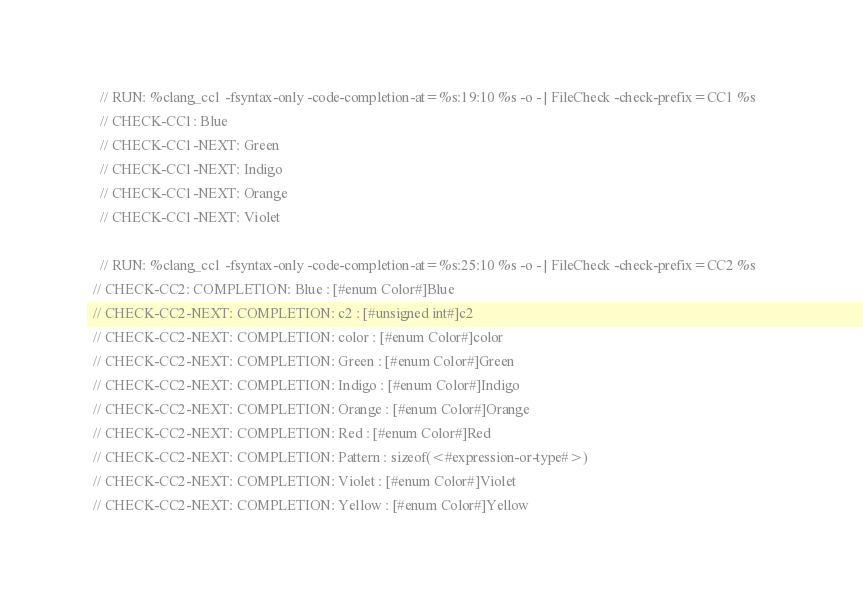<code> <loc_0><loc_0><loc_500><loc_500><_C_>
    // RUN: %clang_cc1 -fsyntax-only -code-completion-at=%s:19:10 %s -o - | FileCheck -check-prefix=CC1 %s
    // CHECK-CC1: Blue
    // CHECK-CC1-NEXT: Green
    // CHECK-CC1-NEXT: Indigo
    // CHECK-CC1-NEXT: Orange
    // CHECK-CC1-NEXT: Violet

    // RUN: %clang_cc1 -fsyntax-only -code-completion-at=%s:25:10 %s -o - | FileCheck -check-prefix=CC2 %s      
  // CHECK-CC2: COMPLETION: Blue : [#enum Color#]Blue
  // CHECK-CC2-NEXT: COMPLETION: c2 : [#unsigned int#]c2
  // CHECK-CC2-NEXT: COMPLETION: color : [#enum Color#]color
  // CHECK-CC2-NEXT: COMPLETION: Green : [#enum Color#]Green
  // CHECK-CC2-NEXT: COMPLETION: Indigo : [#enum Color#]Indigo
  // CHECK-CC2-NEXT: COMPLETION: Orange : [#enum Color#]Orange
  // CHECK-CC2-NEXT: COMPLETION: Red : [#enum Color#]Red
  // CHECK-CC2-NEXT: COMPLETION: Pattern : sizeof(<#expression-or-type#>)
  // CHECK-CC2-NEXT: COMPLETION: Violet : [#enum Color#]Violet
  // CHECK-CC2-NEXT: COMPLETION: Yellow : [#enum Color#]Yellow
</code> 